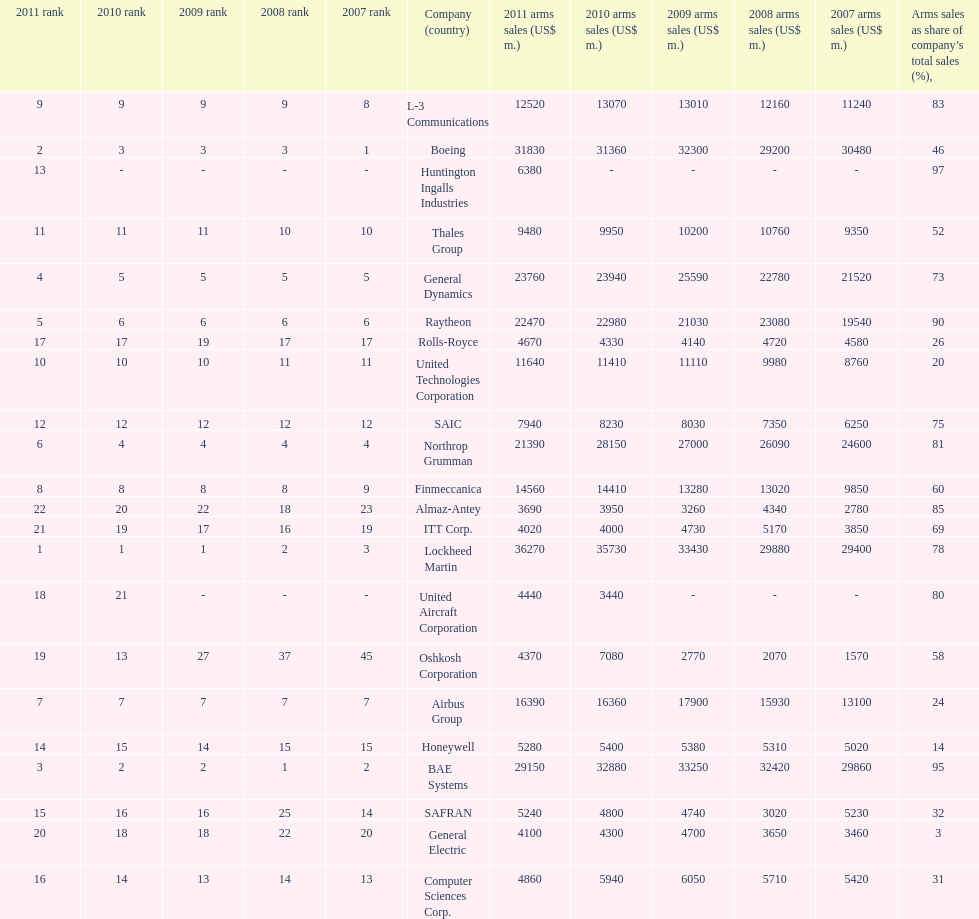Parse the table in full. {'header': ['2011 rank', '2010 rank', '2009 rank', '2008 rank', '2007 rank', 'Company (country)', '2011 arms sales (US$ m.)', '2010 arms sales (US$ m.)', '2009 arms sales (US$ m.)', '2008 arms sales (US$ m.)', '2007 arms sales (US$ m.)', 'Arms sales as share of company’s total sales (%),'], 'rows': [['9', '9', '9', '9', '8', 'L-3 Communications', '12520', '13070', '13010', '12160', '11240', '83'], ['2', '3', '3', '3', '1', 'Boeing', '31830', '31360', '32300', '29200', '30480', '46'], ['13', '-', '-', '-', '-', 'Huntington Ingalls Industries', '6380', '-', '-', '-', '-', '97'], ['11', '11', '11', '10', '10', 'Thales Group', '9480', '9950', '10200', '10760', '9350', '52'], ['4', '5', '5', '5', '5', 'General Dynamics', '23760', '23940', '25590', '22780', '21520', '73'], ['5', '6', '6', '6', '6', 'Raytheon', '22470', '22980', '21030', '23080', '19540', '90'], ['17', '17', '19', '17', '17', 'Rolls-Royce', '4670', '4330', '4140', '4720', '4580', '26'], ['10', '10', '10', '11', '11', 'United Technologies Corporation', '11640', '11410', '11110', '9980', '8760', '20'], ['12', '12', '12', '12', '12', 'SAIC', '7940', '8230', '8030', '7350', '6250', '75'], ['6', '4', '4', '4', '4', 'Northrop Grumman', '21390', '28150', '27000', '26090', '24600', '81'], ['8', '8', '8', '8', '9', 'Finmeccanica', '14560', '14410', '13280', '13020', '9850', '60'], ['22', '20', '22', '18', '23', 'Almaz-Antey', '3690', '3950', '3260', '4340', '2780', '85'], ['21', '19', '17', '16', '19', 'ITT Corp.', '4020', '4000', '4730', '5170', '3850', '69'], ['1', '1', '1', '2', '3', 'Lockheed Martin', '36270', '35730', '33430', '29880', '29400', '78'], ['18', '21', '-', '-', '-', 'United Aircraft Corporation', '4440', '3440', '-', '-', '-', '80'], ['19', '13', '27', '37', '45', 'Oshkosh Corporation', '4370', '7080', '2770', '2070', '1570', '58'], ['7', '7', '7', '7', '7', 'Airbus Group', '16390', '16360', '17900', '15930', '13100', '24'], ['14', '15', '14', '15', '15', 'Honeywell', '5280', '5400', '5380', '5310', '5020', '14'], ['3', '2', '2', '1', '2', 'BAE Systems', '29150', '32880', '33250', '32420', '29860', '95'], ['15', '16', '16', '25', '14', 'SAFRAN', '5240', '4800', '4740', '3020', '5230', '32'], ['20', '18', '18', '22', '20', 'General Electric', '4100', '4300', '4700', '3650', '3460', '3'], ['16', '14', '13', '14', '13', 'Computer Sciences Corp.', '4860', '5940', '6050', '5710', '5420', '31']]} How many different countries are listed? 6. 